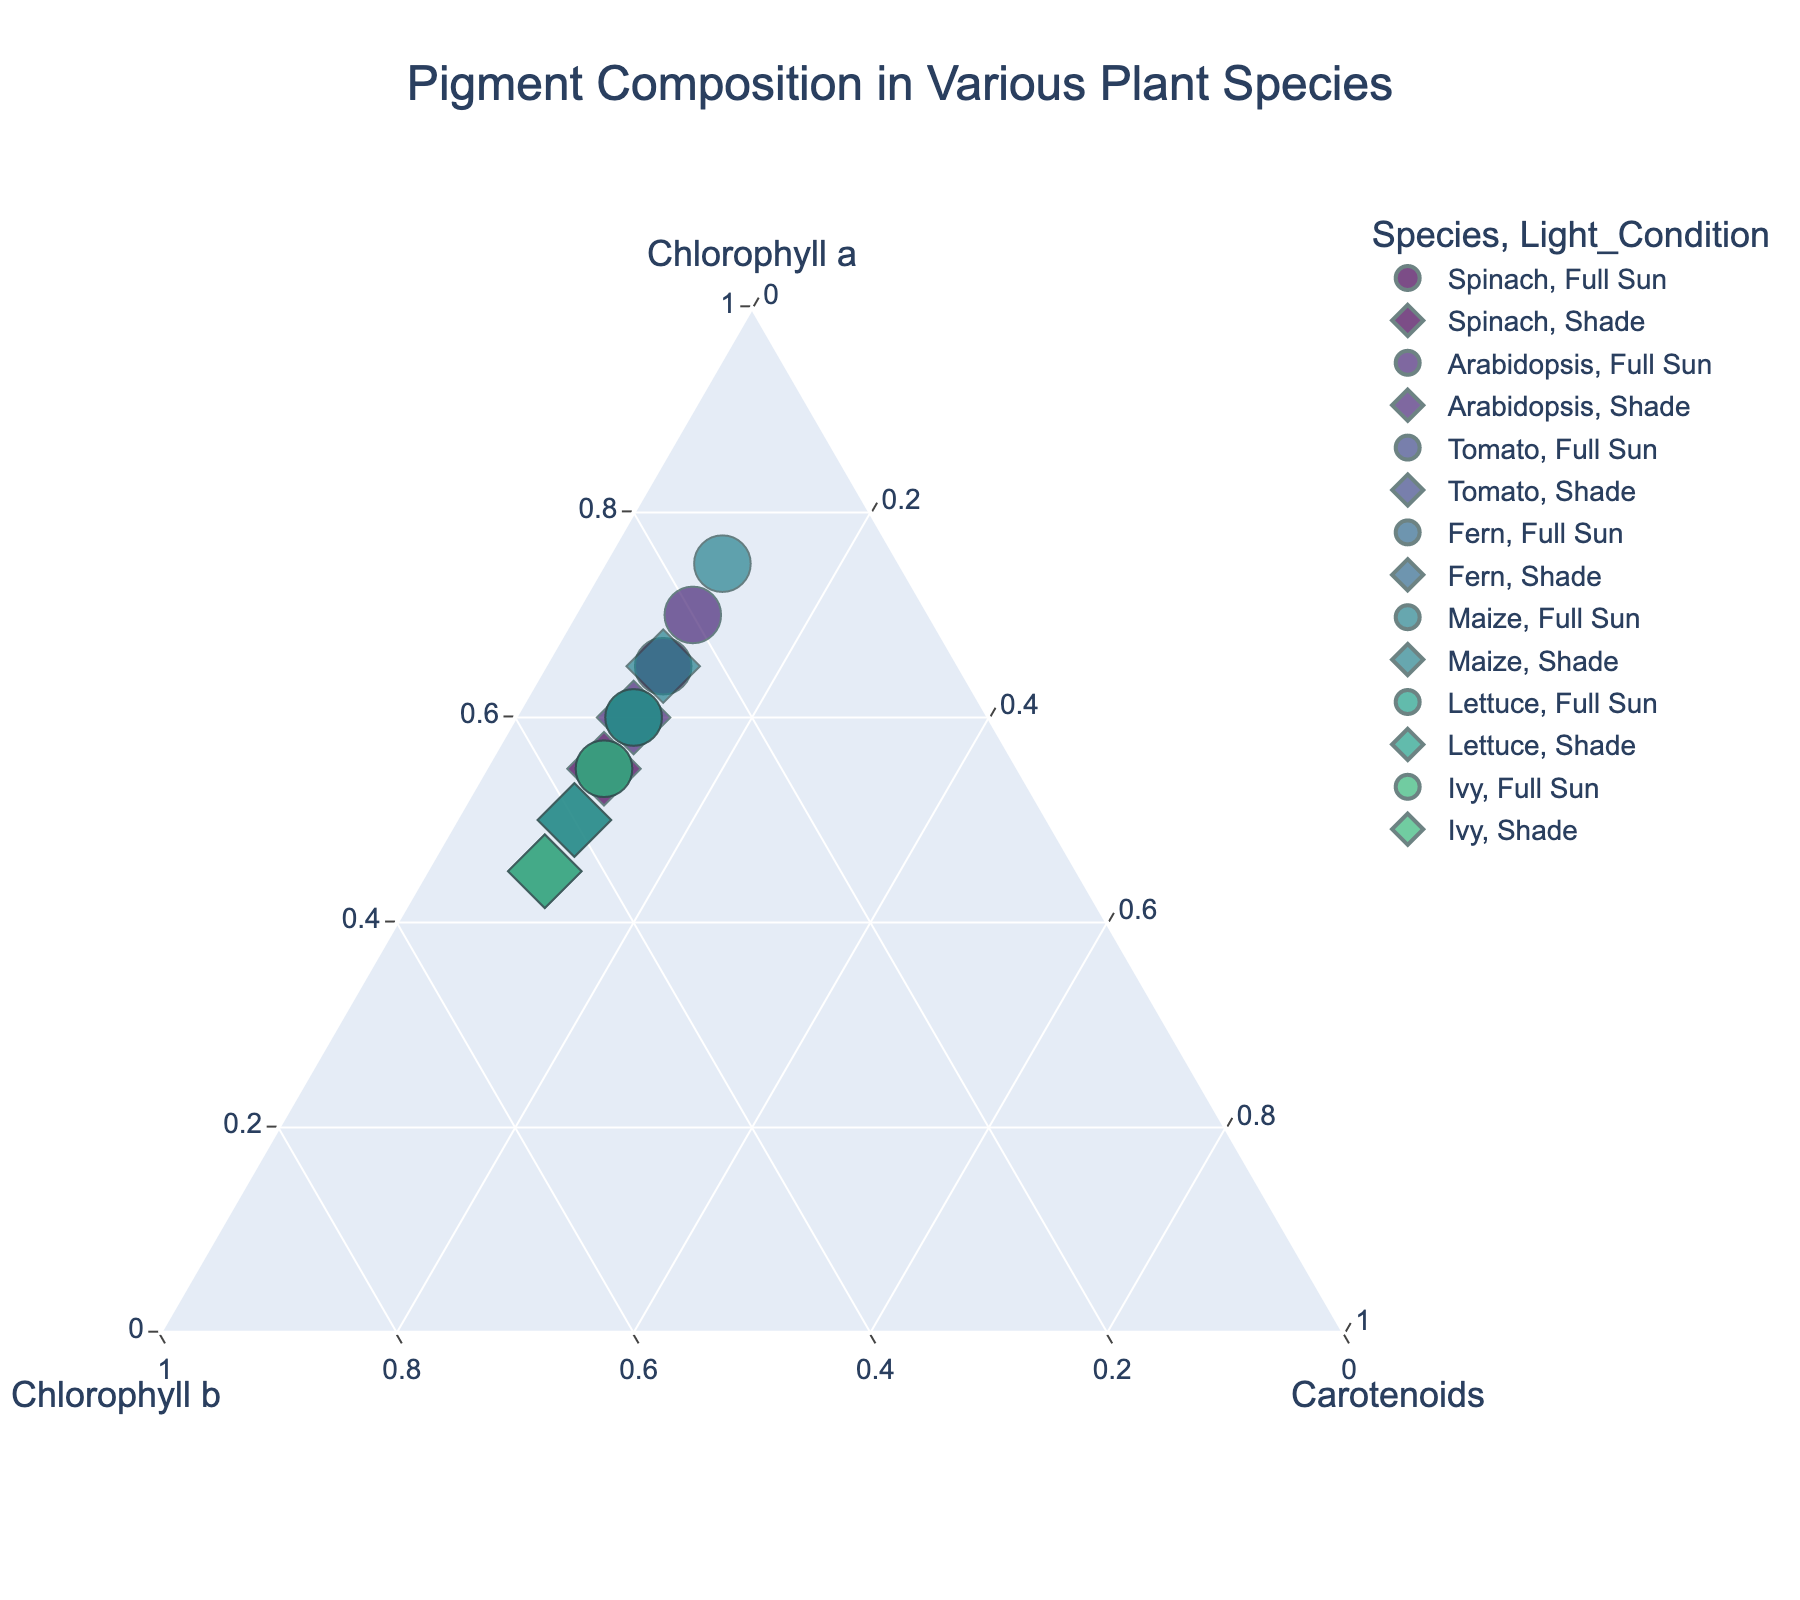What's the title of the plot? The plot title is typically displayed at the top of the figure. In this case, the title is "Pigment Composition in Various Plant Species" as indicated in the code.
Answer: Pigment Composition in Various Plant Species How many different species are represented in the plot? The different species can be identified by the distinct colors in the plot. According to the provided data, we have Spinach, Arabidopsis, Tomato, Fern, Maize, Lettuce, and Ivy, making a total of seven species.
Answer: 7 Which light condition generally has a higher proportion of Chlorophyll a for Ivy? By comparing the positions of Ivy's data points under different light conditions, we see that the point under Full Sun is further up the Chlorophyll a axis compared to the point under Shade.
Answer: Full Sun What is the common proportion of Carotenoids found in all samples? All the data points in the plot line up along the same proportion of Carotenoids, which is 0.10 as seen from the data and the consistent axis labels.
Answer: 0.10 Among the species under Shade condition, which one has the highest proportion of Chlorophyll b? Under Shade, we need to compare the positions of all species data points along the Chlorophyll b axis. Fern under Shade has the most balanced chlorophyll a and b, indicating the highest Chlorophyll b at 0.45.
Answer: Fern What's the difference in the proportion of Chlorophyll a between Maize under Full Sun and Maize under Shade? The proportion of Chlorophyll a for Maize under Full Sun is 0.75 and under Shade is 0.65. The difference is calculated as 0.75 - 0.65 = 0.10.
Answer: 0.10 How does the proportion of Chlorophyll b in Spinach change from Full Sun to Shade? For Spinach, the proportion of Chlorophyll b changes from 0.25 under Full Sun to 0.35 under Shade, which is an increase of 0.10.
Answer: Increases Do any species show equal proportions of Chlorophyll a and Chlorophyll b under any light condition? By looking at the plot, we see that Fern and Ivy under Shade have equal proportions of Chlorophyll a and Chlorophyll b, both at 0.45 each.
Answer: Yes Which species has the highest proportion of Chlorophyll a under Full Sun condition? By comparing the positions of each species along the Chlorophyll a axis under Full Sun, Maize has the highest proportion of 0.75.
Answer: Maize 